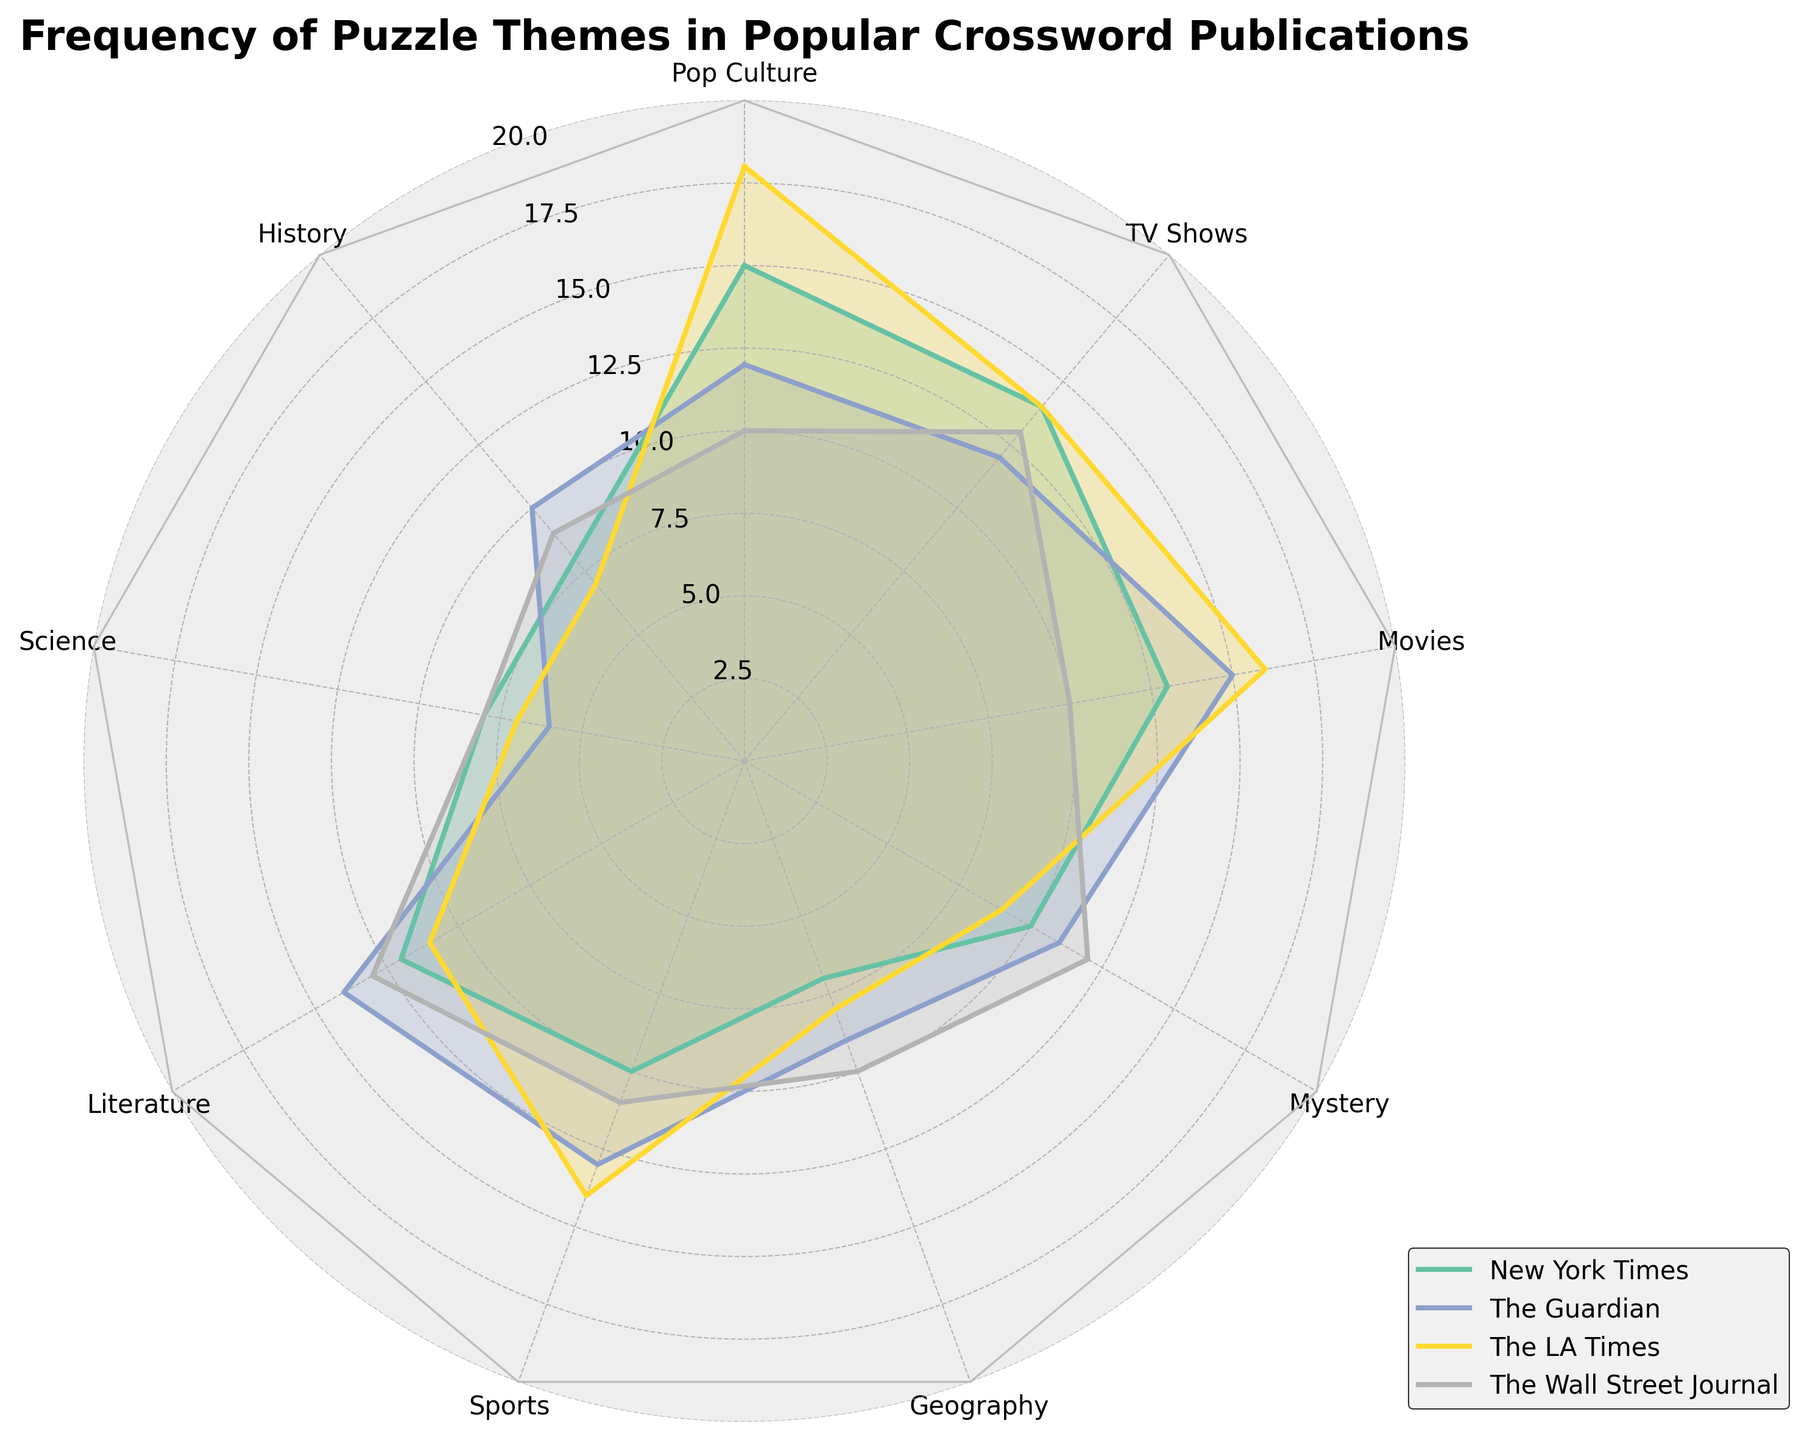What is the title of the radar chart? The title is usually located at the top of the chart. Here, it is clearly labeled.
Answer: Frequency of Puzzle Themes in Popular Crossword Publications Which category has the highest frequency for The LA Times? We need to look for the highest value among the points representing The LA Times. The 'Movies' category has the highest value of 16 for The LA Times.
Answer: Movies How many categories are there in total? By counting the labels around the edge of the radar plot, we can find the total number of categories. There are 9 categories in the plot.
Answer: 9 Which publication has the lowest frequency in the 'History' category? By comparing the "History" category values of all publications, The LA Times has the lowest value of 7.
Answer: The LA Times What is the average frequency of the 'Sports' category across all publications? Add the frequencies of the 'Sports' category for all publications and divide by the number of publications: (10 + 13 + 14 + 11)/4 = 48/4.
Answer: 12 Which category has the most balanced distribution across all publications? A balanced distribution means frequencies are similar across publications. The 'Science' category has very similar values: 8, 6, 7, and 8.
Answer: Science In the 'TV Shows' category, which publication shows the greatest frequency? Compare the data points for the 'TV Shows' category among all publications. The New York Times has the greatest frequency of 14.
Answer: The New York Times Compare the frequency of 'Pop Culture' between The New York Times and The Wall Street Journal. Which one is higher? The data shows 'Pop Culture' values of 15 for The New York Times and 10 for The Wall Street Journal. The New York Times is higher.
Answer: The New York Times What is the total frequency of the 'Literature' category across all publications? Add the frequencies of the 'Literature' category for all publications: 12 + 14 + 11 + 13. The sum is 50.
Answer: 50 Determine the difference in frequency of 'Movies' between the highest and lowest publications. Identify the highest and lowest values in the 'Movies' category: highest is 16 (The LA Times) and lowest is 10 (The Wall Street Journal). The difference is 16 - 10.
Answer: 6 